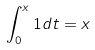Convert formula to latex. <formula><loc_0><loc_0><loc_500><loc_500>\int _ { 0 } ^ { x } 1 d t = x</formula> 